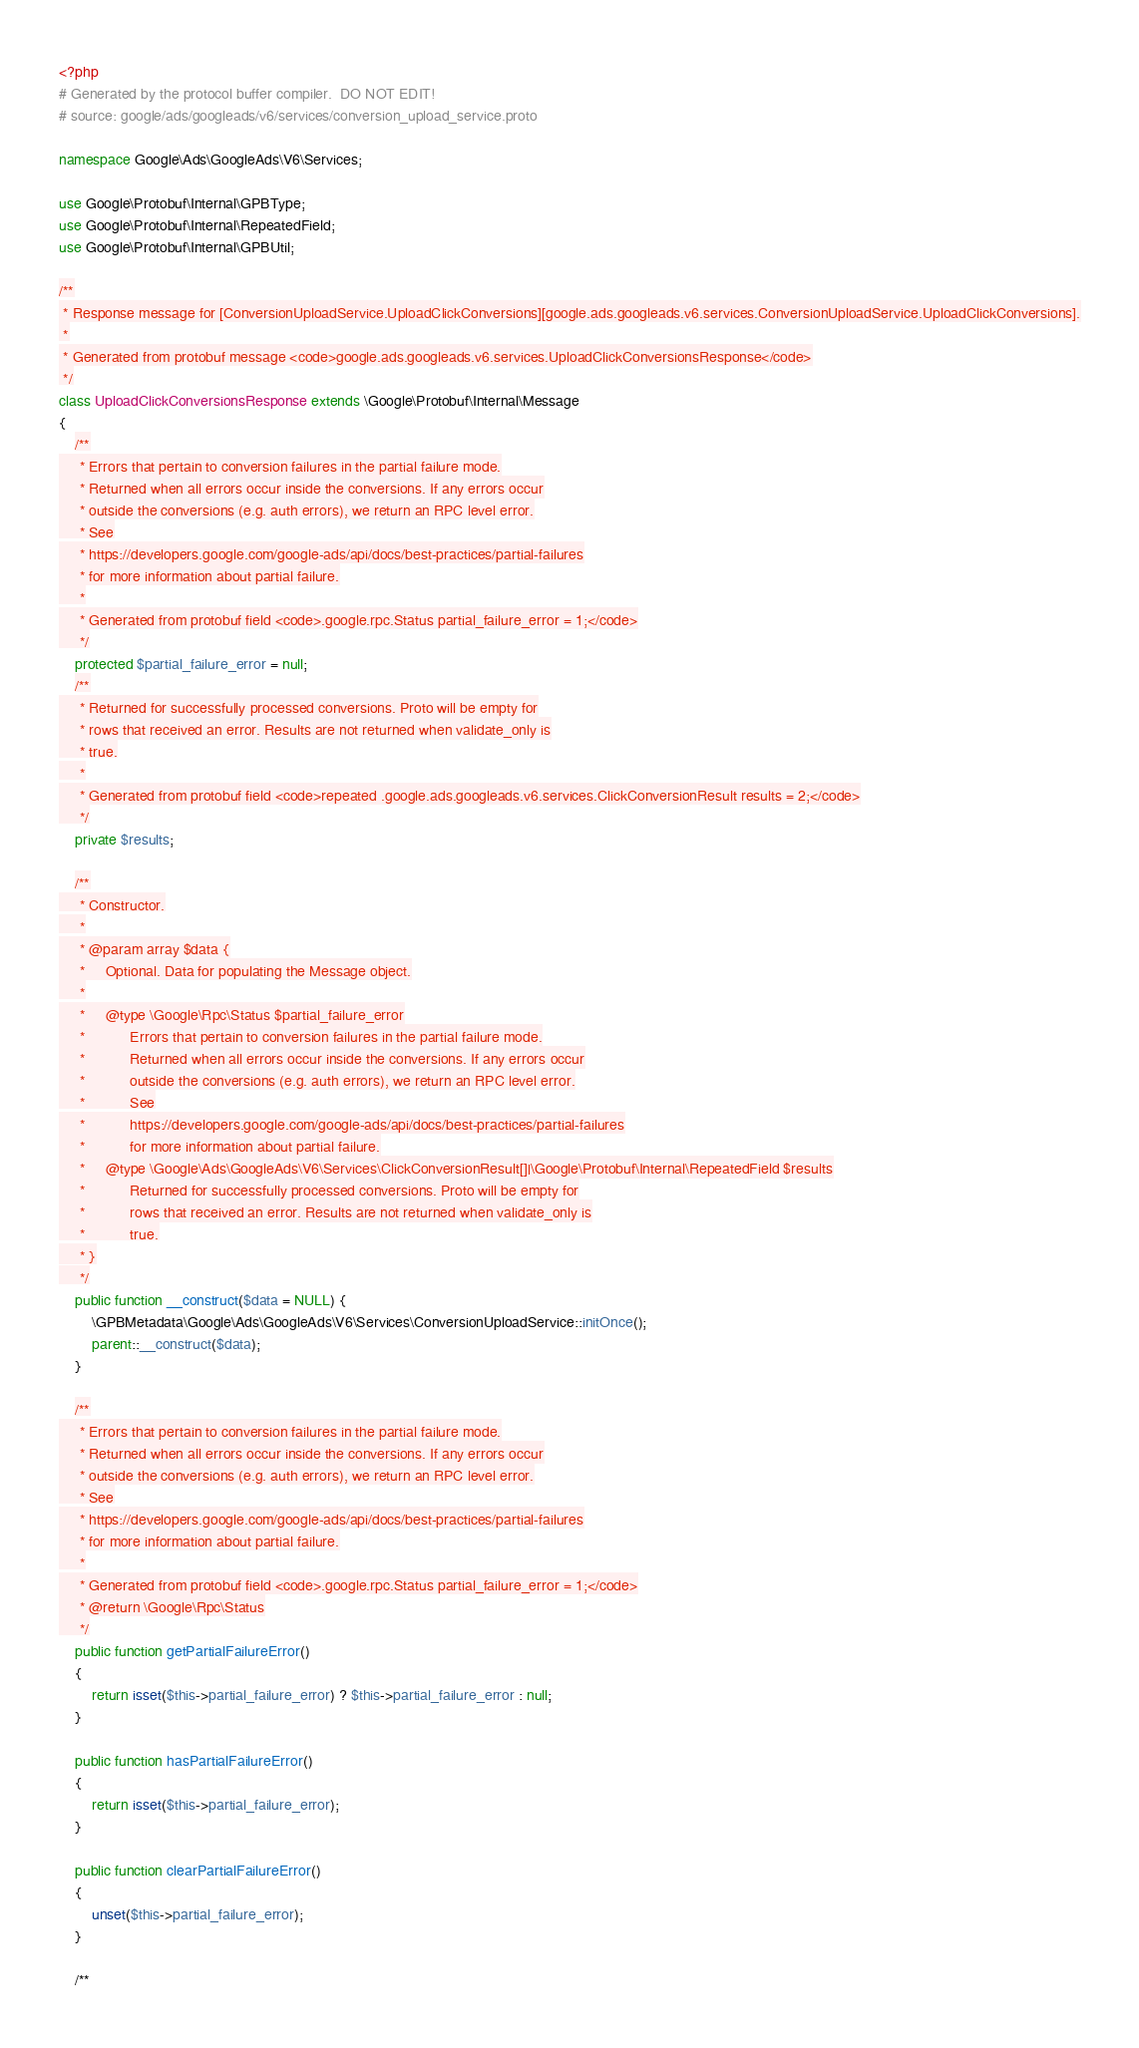Convert code to text. <code><loc_0><loc_0><loc_500><loc_500><_PHP_><?php
# Generated by the protocol buffer compiler.  DO NOT EDIT!
# source: google/ads/googleads/v6/services/conversion_upload_service.proto

namespace Google\Ads\GoogleAds\V6\Services;

use Google\Protobuf\Internal\GPBType;
use Google\Protobuf\Internal\RepeatedField;
use Google\Protobuf\Internal\GPBUtil;

/**
 * Response message for [ConversionUploadService.UploadClickConversions][google.ads.googleads.v6.services.ConversionUploadService.UploadClickConversions].
 *
 * Generated from protobuf message <code>google.ads.googleads.v6.services.UploadClickConversionsResponse</code>
 */
class UploadClickConversionsResponse extends \Google\Protobuf\Internal\Message
{
    /**
     * Errors that pertain to conversion failures in the partial failure mode.
     * Returned when all errors occur inside the conversions. If any errors occur
     * outside the conversions (e.g. auth errors), we return an RPC level error.
     * See
     * https://developers.google.com/google-ads/api/docs/best-practices/partial-failures
     * for more information about partial failure.
     *
     * Generated from protobuf field <code>.google.rpc.Status partial_failure_error = 1;</code>
     */
    protected $partial_failure_error = null;
    /**
     * Returned for successfully processed conversions. Proto will be empty for
     * rows that received an error. Results are not returned when validate_only is
     * true.
     *
     * Generated from protobuf field <code>repeated .google.ads.googleads.v6.services.ClickConversionResult results = 2;</code>
     */
    private $results;

    /**
     * Constructor.
     *
     * @param array $data {
     *     Optional. Data for populating the Message object.
     *
     *     @type \Google\Rpc\Status $partial_failure_error
     *           Errors that pertain to conversion failures in the partial failure mode.
     *           Returned when all errors occur inside the conversions. If any errors occur
     *           outside the conversions (e.g. auth errors), we return an RPC level error.
     *           See
     *           https://developers.google.com/google-ads/api/docs/best-practices/partial-failures
     *           for more information about partial failure.
     *     @type \Google\Ads\GoogleAds\V6\Services\ClickConversionResult[]|\Google\Protobuf\Internal\RepeatedField $results
     *           Returned for successfully processed conversions. Proto will be empty for
     *           rows that received an error. Results are not returned when validate_only is
     *           true.
     * }
     */
    public function __construct($data = NULL) {
        \GPBMetadata\Google\Ads\GoogleAds\V6\Services\ConversionUploadService::initOnce();
        parent::__construct($data);
    }

    /**
     * Errors that pertain to conversion failures in the partial failure mode.
     * Returned when all errors occur inside the conversions. If any errors occur
     * outside the conversions (e.g. auth errors), we return an RPC level error.
     * See
     * https://developers.google.com/google-ads/api/docs/best-practices/partial-failures
     * for more information about partial failure.
     *
     * Generated from protobuf field <code>.google.rpc.Status partial_failure_error = 1;</code>
     * @return \Google\Rpc\Status
     */
    public function getPartialFailureError()
    {
        return isset($this->partial_failure_error) ? $this->partial_failure_error : null;
    }

    public function hasPartialFailureError()
    {
        return isset($this->partial_failure_error);
    }

    public function clearPartialFailureError()
    {
        unset($this->partial_failure_error);
    }

    /**</code> 